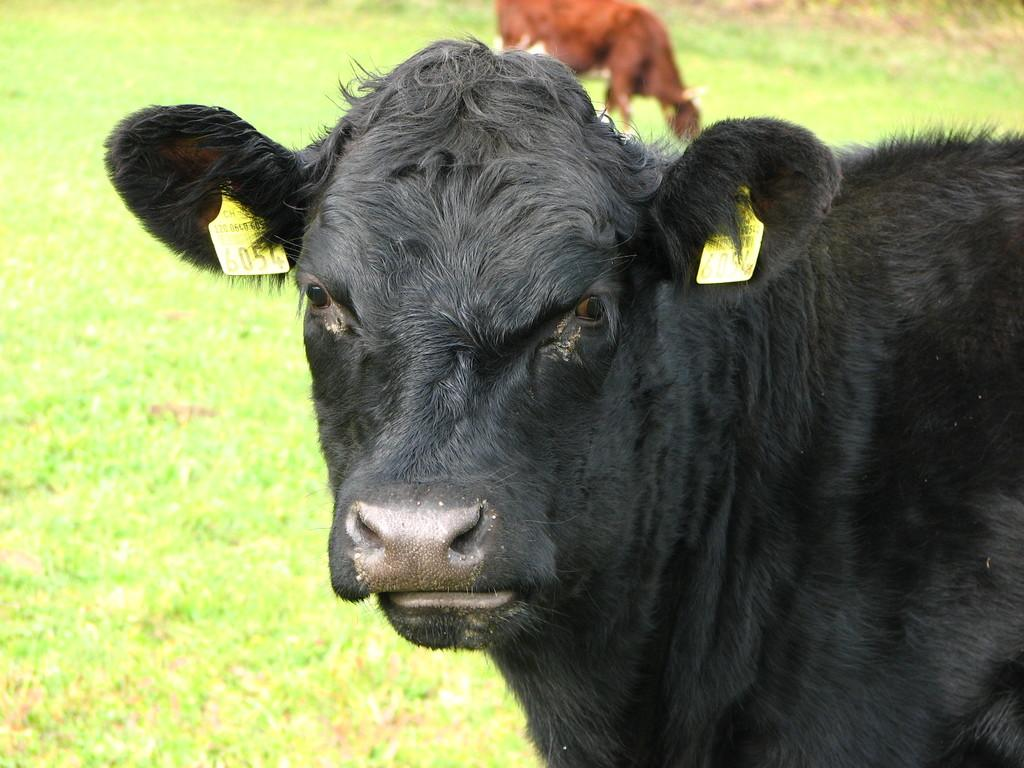What type of living organisms can be seen in the image? There are animals visible in the image. Where are the animals located in the image? The animals are on the right side of the image and in the background. What type of vegetation is present in the image? There is green grass in the image. What type of pest can be seen crawling on the soda can in the image? There is no soda can or pest present in the image. 